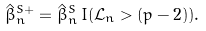<formula> <loc_0><loc_0><loc_500><loc_500>\hat { \beta } _ { n } ^ { S + } = \hat { \beta } _ { n } ^ { S } \, I ( \mathcal { L } _ { n } > ( p - 2 ) ) .</formula> 